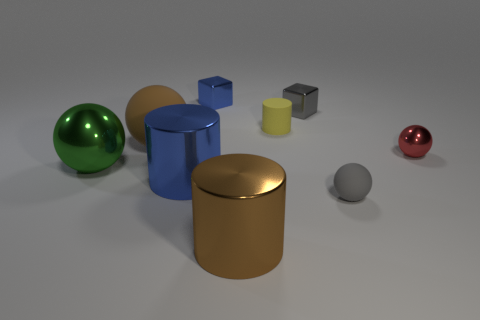Are there any tiny rubber objects on the right side of the gray thing behind the matte ball in front of the big shiny ball?
Offer a terse response. Yes. There is a tiny gray object that is in front of the yellow object; is its shape the same as the red metallic thing?
Your response must be concise. Yes. What color is the other ball that is the same material as the green sphere?
Your answer should be compact. Red. What number of brown cylinders have the same material as the green ball?
Your response must be concise. 1. There is a big sphere that is to the right of the shiny ball to the left of the gray object that is behind the tiny matte ball; what color is it?
Make the answer very short. Brown. Do the green sphere and the yellow thing have the same size?
Provide a succinct answer. No. Are there any other things that have the same shape as the small red shiny thing?
Your answer should be compact. Yes. What number of things are either metal objects that are on the right side of the brown sphere or tiny gray metal cubes?
Keep it short and to the point. 5. Do the tiny yellow matte object and the tiny red thing have the same shape?
Your response must be concise. No. What number of other objects are there of the same size as the red metallic ball?
Give a very brief answer. 4. 